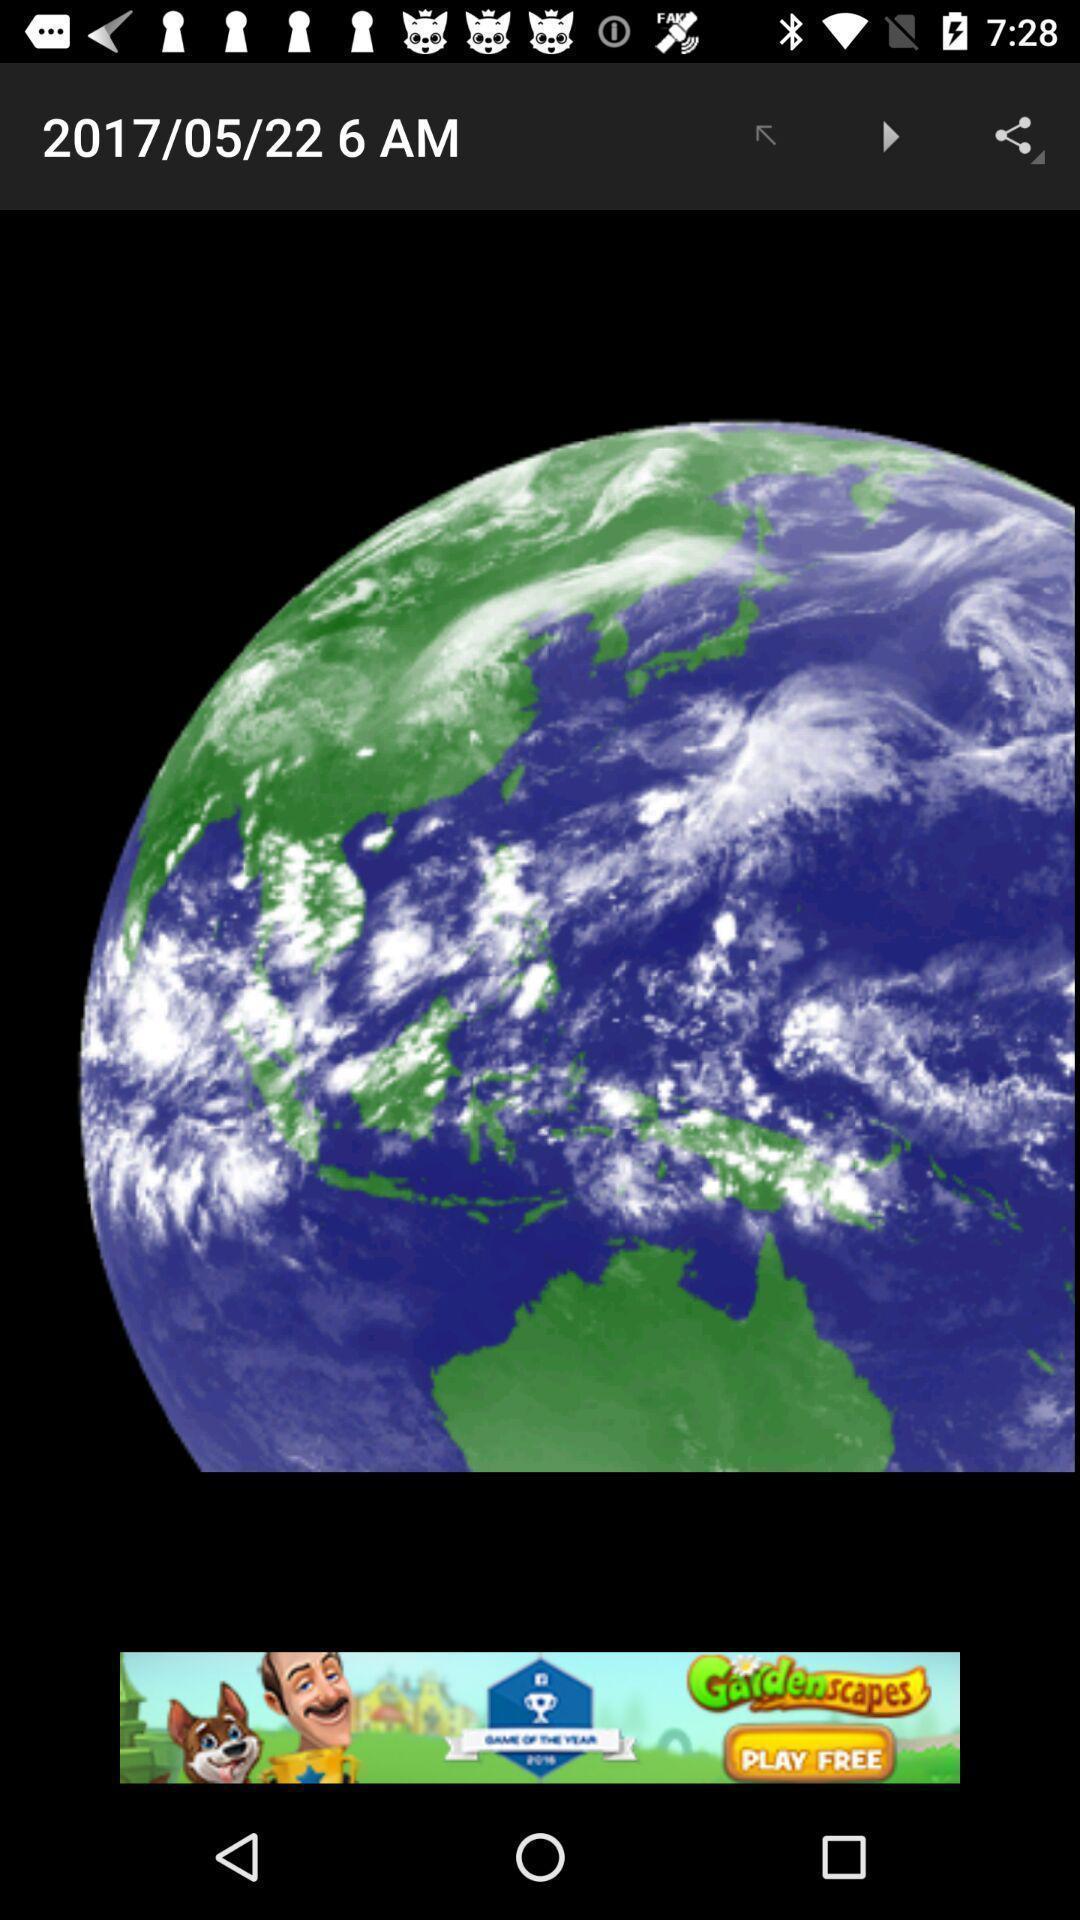Describe this image in words. Window displaying an earth picture. 